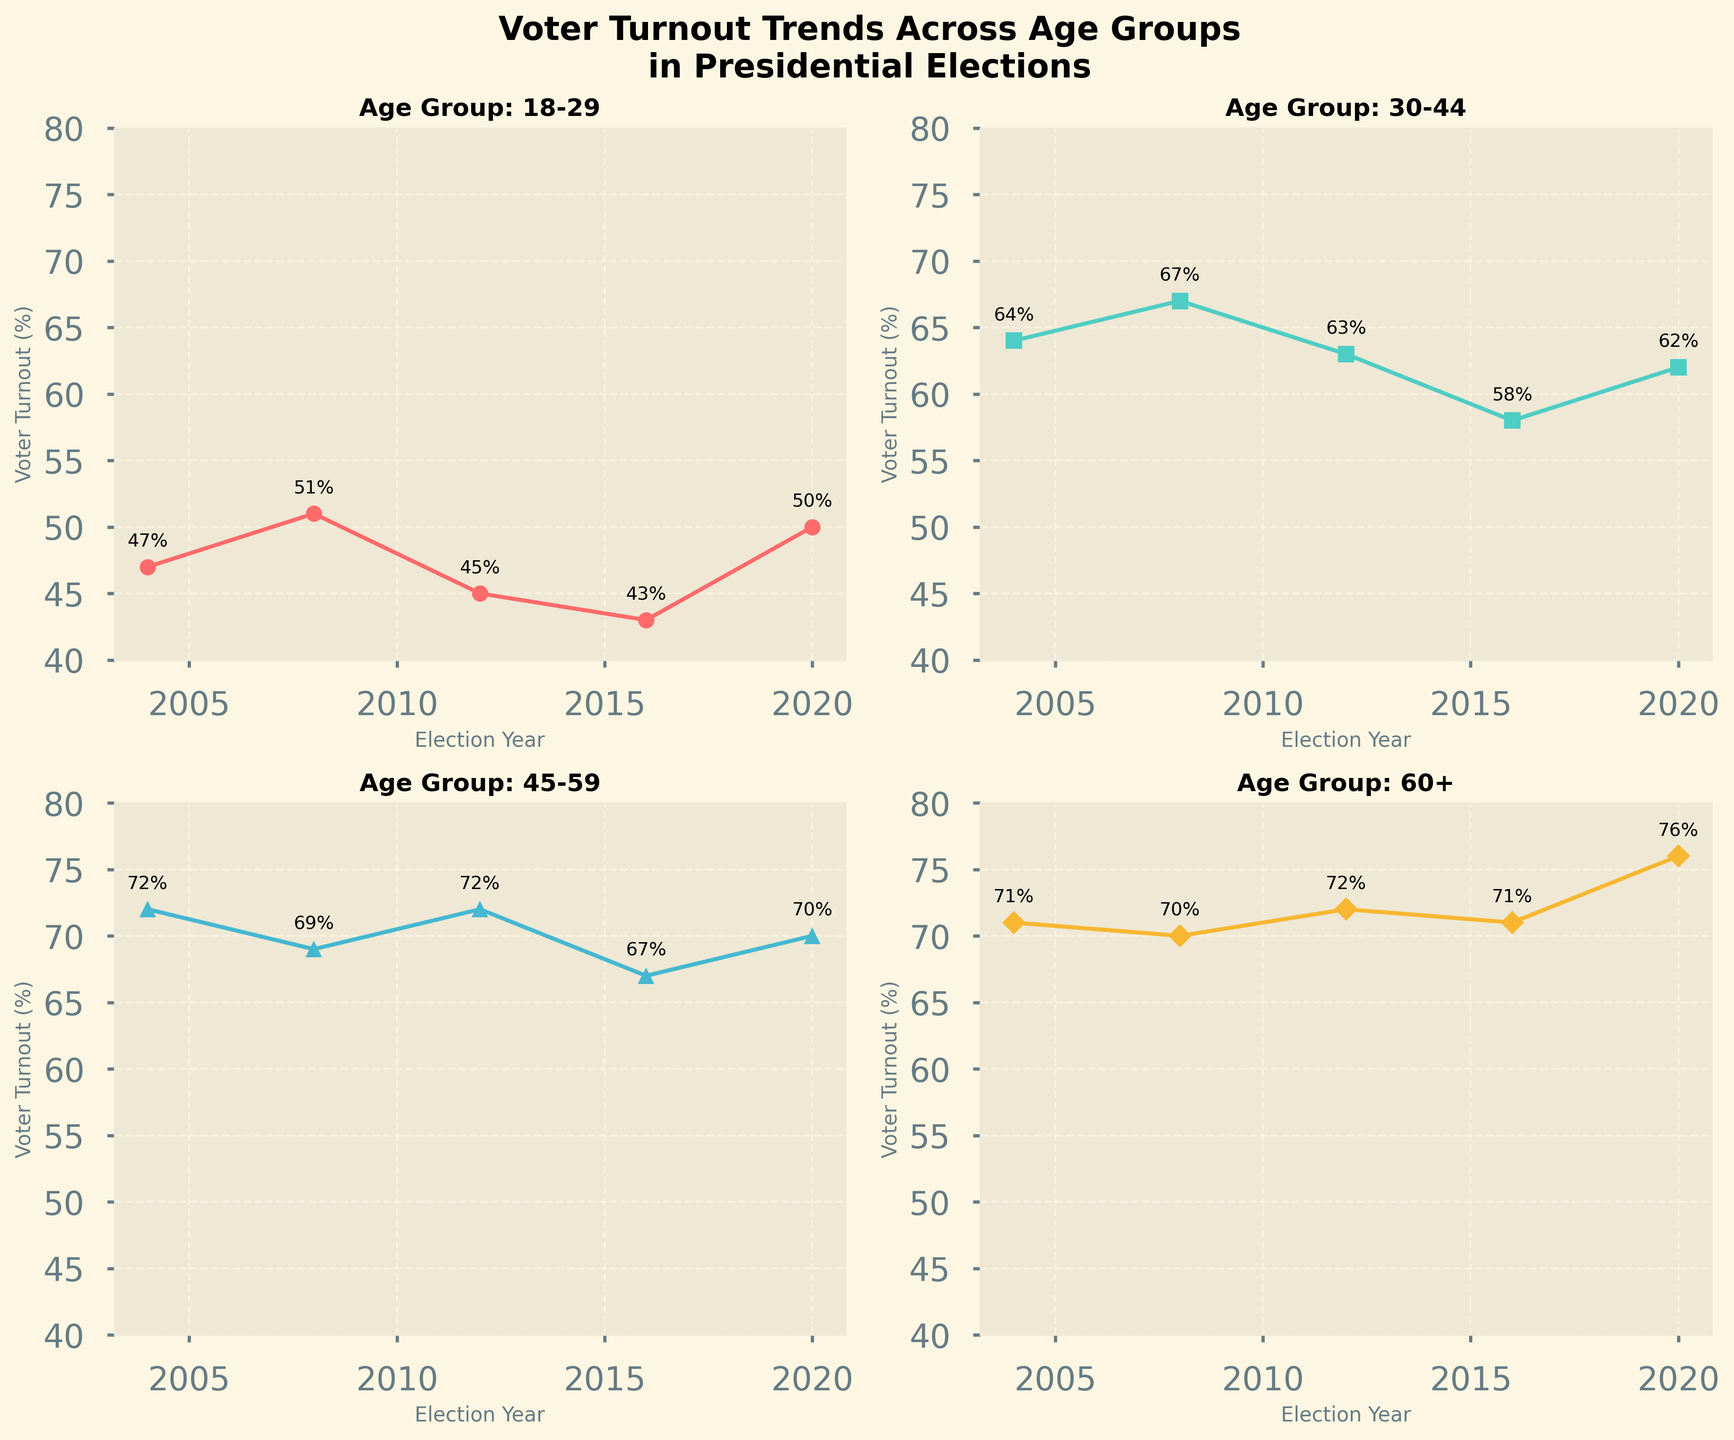What is the voter turnout percentage for the 18-29 age group in the 2008 election? First, locate the subplot corresponding to the 18-29 age group. Then, find the data point for the 2008 election. The value next to this data point represents the voter turnout percentage.
Answer: 51% How did the voter turnout percentage for the 60+ age group change from the 2004 to the 2020 elections? Locate the subplot for the 60+ age group. Check the voter turnout percentages for the years 2004 and 2020. Subtract the 2004 value from the 2020 value to find the change. (76% - 71%)
Answer: Increased by 5% Which age group had the highest voter turnout in the 2020 election? Check the subplots for all age groups and compare the turnout percentages for the year 2020. Identify the age group with the highest percentage. The 60+ age group had a turnout of 76%, which is the highest.
Answer: 60+ Compare the voter turnout trends of the 30-44 and 45-59 age groups over the five elections. Which group had more consistent percentages? Look at both subplots for the 30-44 and 45-59 age groups. Note the variation in percentages across all five elections. The 45-59 age group shows less fluctuation in percentages compared to the 30-44 age group.
Answer: 45-59 age group What is the average voter turnout percentage for the 45-59 age group across all five elections? Locate the subplot for the 45-59 age group. Find the voter turnout percentages for all five elections. Add these values together and divide by the number of elections (5). (72+69+72+67+70)/5
Answer: 70% In which election year did the 18-29 age group experience the largest decrease in voter turnout compared to the previous election? Check the subplot for the 18-29 age group. Calculate the differences in voter turnout between consecutive election years. The largest decrease is from 2008 to 2012 (51% - 45%)
Answer: 2012 What is the range of voter turnout percentages for the 30-44 age group over the five elections? Find the highest and lowest percentages in the subplot for the 30-44 age group. Subtract the lowest percentage from the highest to find the range. Highest is 67% (2008), lowest is 58% (2016). 67 - 58
Answer: 9% Which age group experienced the most significant increase in voter turnout from 2016 to 2020? Compare the changes in voter turnout for each age group between 2016 and 2020. Subtract the 2016 values from the 2020 values for each group. The 60+ age group showed the most considerable increase (76% - 71%).
Answer: 60+ age group What was the voter turnout percentage for the 45-59 age group in the 2004 and 2016 elections, and what is the difference between these two percentages? Locate the subplot for the 45-59 age group and retrieve the percentages for 2004 and 2016. Subtract the 2016 percentage from the 2004 percentage to find the difference. (72% - 67%)
Answer: 5% 